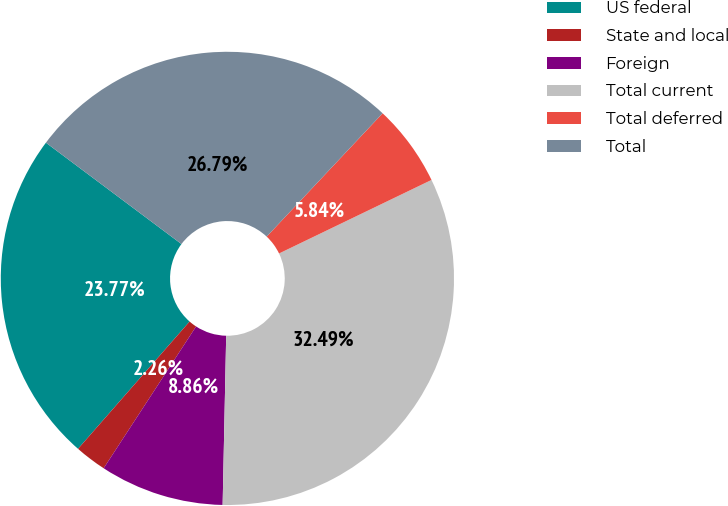<chart> <loc_0><loc_0><loc_500><loc_500><pie_chart><fcel>US federal<fcel>State and local<fcel>Foreign<fcel>Total current<fcel>Total deferred<fcel>Total<nl><fcel>23.77%<fcel>2.26%<fcel>8.86%<fcel>32.49%<fcel>5.84%<fcel>26.79%<nl></chart> 